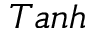Convert formula to latex. <formula><loc_0><loc_0><loc_500><loc_500>T a n h</formula> 